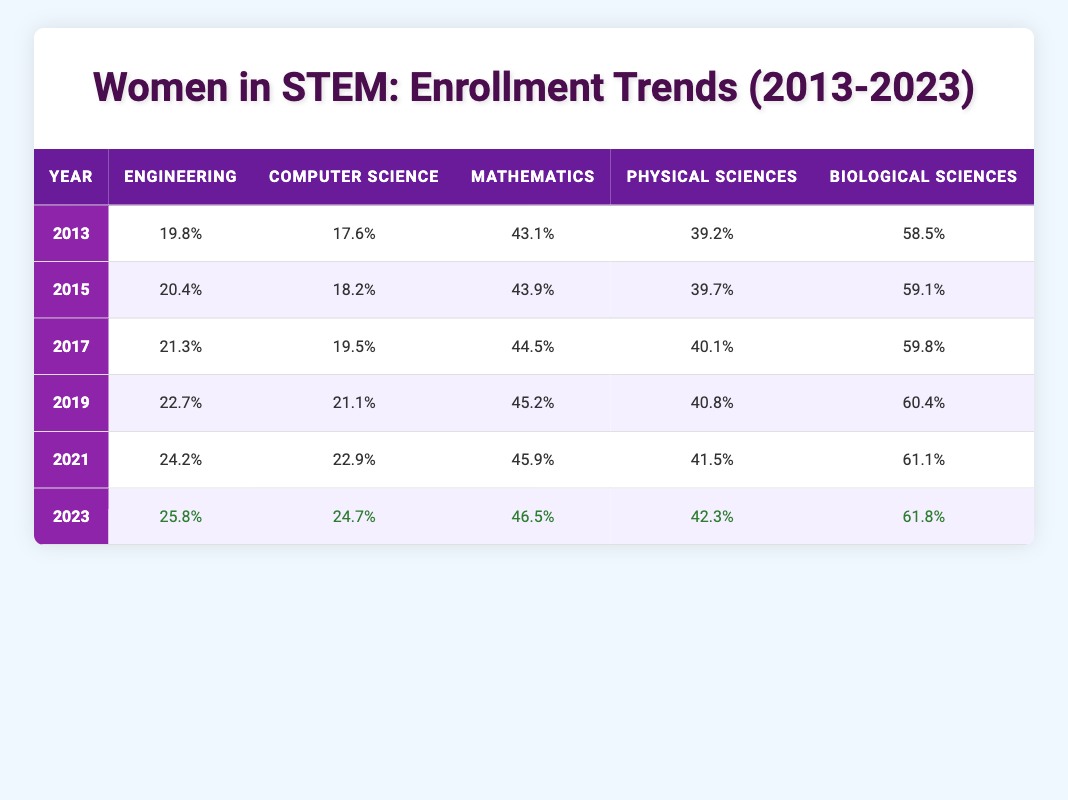What was the enrollment percentage of women in Engineering in 2013? In the table under the "Year" column for 2013, the corresponding value in the Engineering column is 19.8%.
Answer: 19.8% What is the enrollment percentage of women in Computer Science for the year 2021? The table indicates that in 2021, the enrollment percentage for Computer Science was 22.9%.
Answer: 22.9% Has the enrollment of women in Biological Sciences increased from 2013 to 2023? From the table, the Biological Sciences percentage was 58.5% in 2013 and increased to 61.8% in 2023, indicating a rise over the years.
Answer: Yes What is the difference in the enrollment percentage of women in Mathematics between 2013 and 2023? The enrollment percentage for Mathematics in 2013 was 43.1% and in 2023 it was 46.5%. The difference is calculated as 46.5% - 43.1% = 3.4%.
Answer: 3.4% What was the average percentage of women enrolled in Physical Sciences over the years provided? To find the average, sum the Physical Sciences percentages (39.2 + 39.7 + 40.1 + 40.8 + 41.5 + 42.3) = 243.6. Then divide this sum by the number of data points (6), which gives approximately 40.6%.
Answer: 40.6% Was the enrollment of women in Computer Science higher in 2023 compared to 2019? In 2019, the percentage was 21.1% and in 2023 it increased to 24.7%, which confirms it was higher in 2023.
Answer: Yes What is the trend for women’s enrollment in Engineering from 2013 to 2023? By analyzing the table, the percentages in Engineering are 19.8%, 20.4%, 21.3%, 22.7%, 24.2%, and 25.8%, respectively. This shows a consistent increase each year, indicating a positive trend.
Answer: Positive trend Comparing the percentages for Biological Sciences, which year saw the largest increase from the previous year? Looking at the Biological Sciences data: the increases were from 58.5% (2013) to 59.1% (2015), 59.1% to 59.8% (2017), 59.8% to 60.4% (2019), 60.4% to 61.1% (2021), and 61.1% to 61.8% (2023). The largest increase was from 60.4% (2019) to 61.1% (2021) which is 0.7%.
Answer: 0.7% In which year did the percentage of women in Mathematics first exceed 45%? From the table, the percentages for Mathematics are 43.1%, 43.9%, 44.5%, 45.2%, 45.9%, and 46.5%. The first year to exceed 45% was 2019.
Answer: 2019 